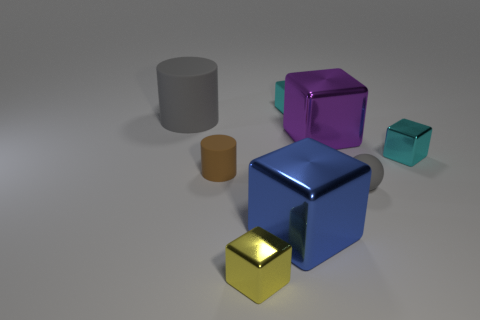What is the size of the matte cylinder that is the same color as the ball?
Your answer should be very brief. Large. There is another big object that is the same shape as the large blue thing; what is its color?
Your response must be concise. Purple. Are there any small yellow blocks behind the small cube behind the purple thing?
Offer a terse response. No. The blue shiny block has what size?
Give a very brief answer. Large. What is the shape of the object that is left of the yellow block and in front of the large cylinder?
Provide a short and direct response. Cylinder. What number of green objects are either tiny cylinders or big matte objects?
Your answer should be compact. 0. Do the rubber object right of the blue cube and the block on the right side of the sphere have the same size?
Your answer should be very brief. Yes. How many things are blue metallic objects or red rubber balls?
Keep it short and to the point. 1. Is there a tiny red matte thing that has the same shape as the purple shiny object?
Keep it short and to the point. No. Are there fewer blue metal objects than cylinders?
Make the answer very short. Yes. 